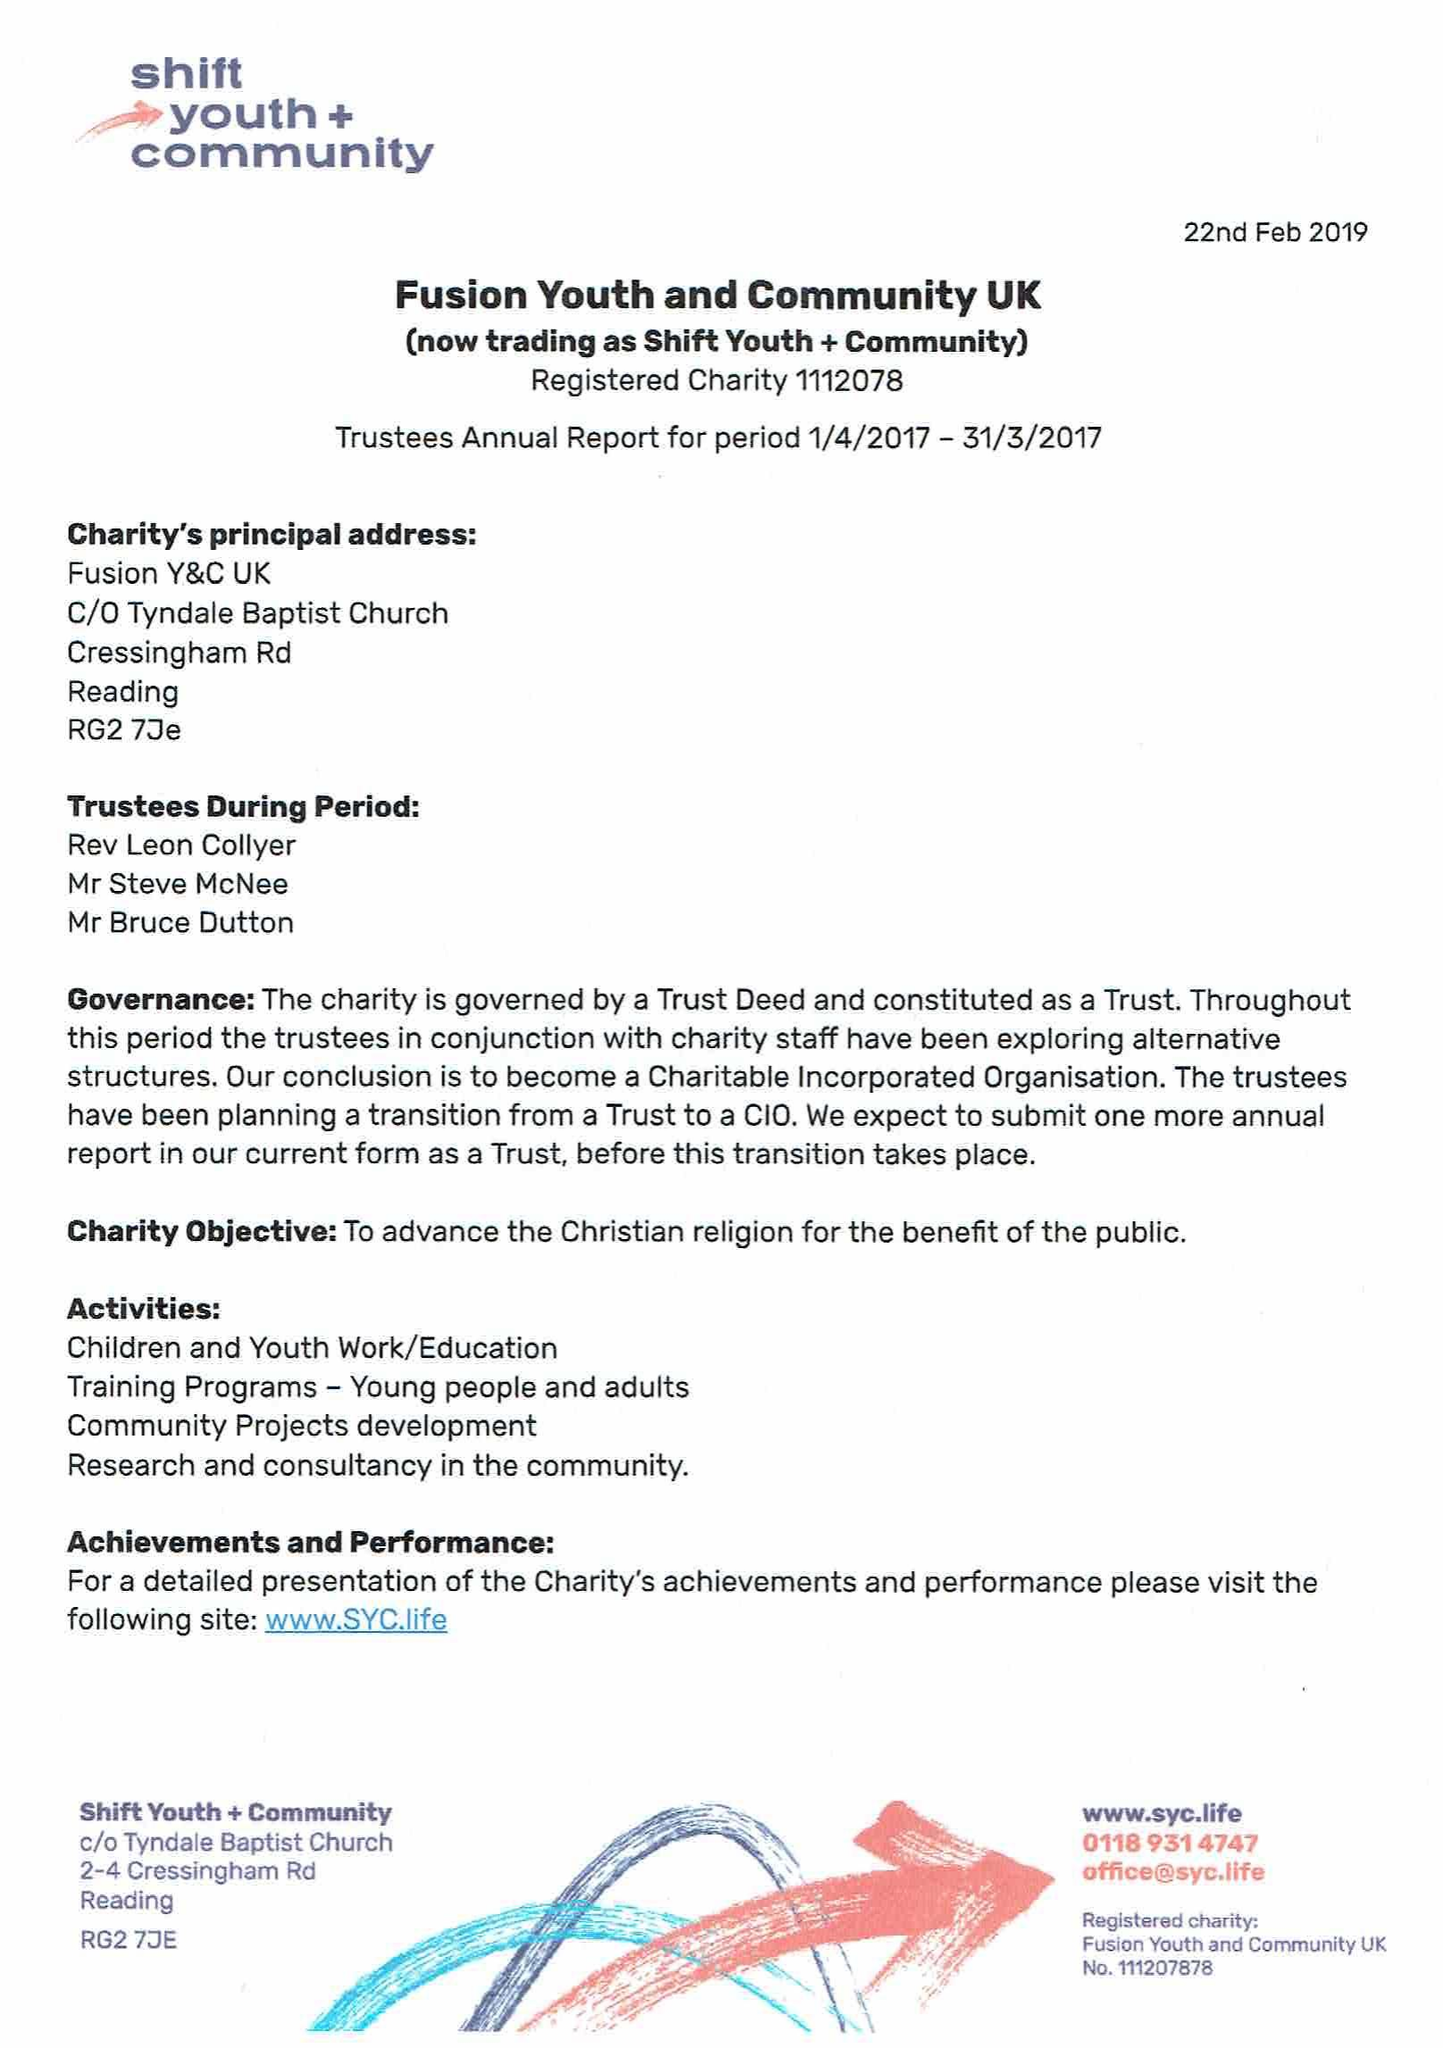What is the value for the address__postcode?
Answer the question using a single word or phrase. RG2 7JE 